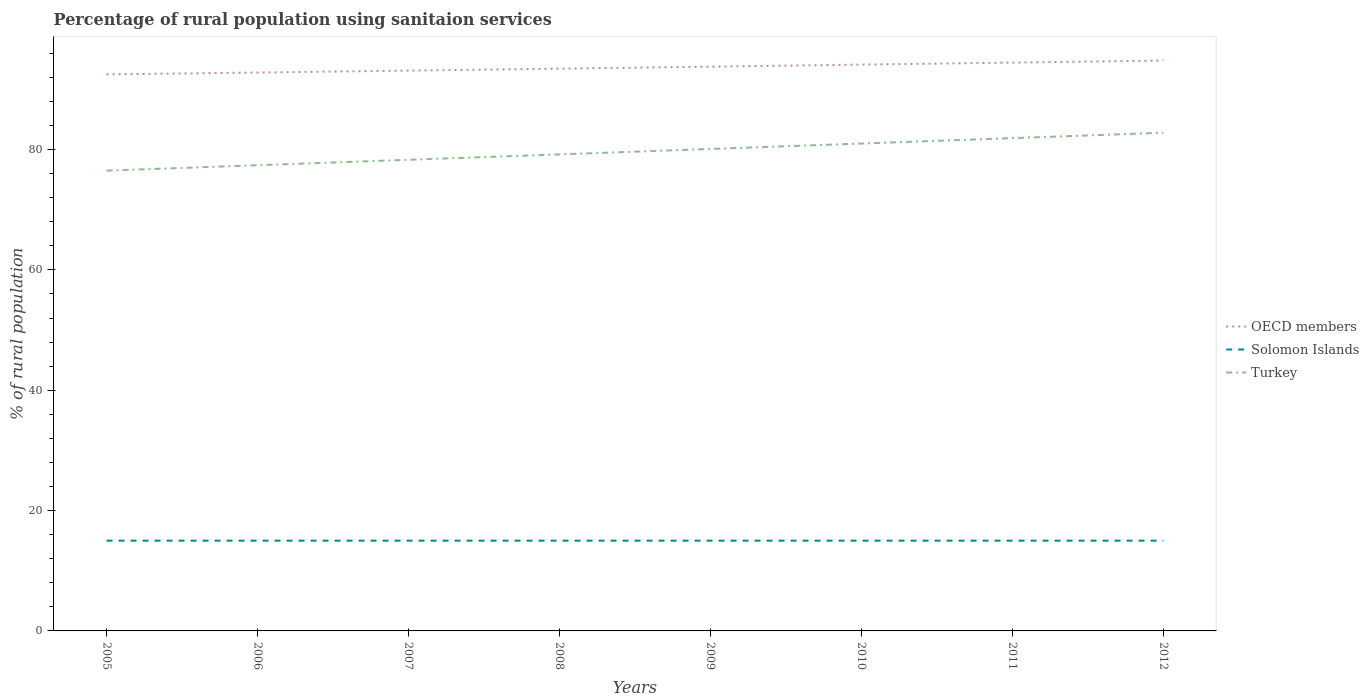Does the line corresponding to OECD members intersect with the line corresponding to Solomon Islands?
Keep it short and to the point. No. Across all years, what is the maximum percentage of rural population using sanitaion services in Solomon Islands?
Make the answer very short. 15. What is the total percentage of rural population using sanitaion services in Turkey in the graph?
Provide a succinct answer. -2.7. What is the difference between the highest and the second highest percentage of rural population using sanitaion services in OECD members?
Provide a succinct answer. 2.29. What is the difference between the highest and the lowest percentage of rural population using sanitaion services in Turkey?
Your answer should be very brief. 4. How many lines are there?
Your answer should be compact. 3. What is the difference between two consecutive major ticks on the Y-axis?
Ensure brevity in your answer.  20. Does the graph contain grids?
Your answer should be compact. No. Where does the legend appear in the graph?
Offer a terse response. Center right. How many legend labels are there?
Your response must be concise. 3. What is the title of the graph?
Provide a succinct answer. Percentage of rural population using sanitaion services. What is the label or title of the X-axis?
Give a very brief answer. Years. What is the label or title of the Y-axis?
Your answer should be compact. % of rural population. What is the % of rural population of OECD members in 2005?
Make the answer very short. 92.5. What is the % of rural population in Solomon Islands in 2005?
Provide a short and direct response. 15. What is the % of rural population of Turkey in 2005?
Your response must be concise. 76.5. What is the % of rural population of OECD members in 2006?
Your response must be concise. 92.8. What is the % of rural population in Turkey in 2006?
Your response must be concise. 77.4. What is the % of rural population of OECD members in 2007?
Provide a succinct answer. 93.13. What is the % of rural population of Solomon Islands in 2007?
Offer a very short reply. 15. What is the % of rural population in Turkey in 2007?
Make the answer very short. 78.3. What is the % of rural population in OECD members in 2008?
Keep it short and to the point. 93.44. What is the % of rural population in Solomon Islands in 2008?
Offer a very short reply. 15. What is the % of rural population in Turkey in 2008?
Make the answer very short. 79.2. What is the % of rural population in OECD members in 2009?
Offer a very short reply. 93.77. What is the % of rural population in Turkey in 2009?
Provide a succinct answer. 80.1. What is the % of rural population of OECD members in 2010?
Provide a succinct answer. 94.12. What is the % of rural population in Solomon Islands in 2010?
Offer a very short reply. 15. What is the % of rural population in Turkey in 2010?
Make the answer very short. 81. What is the % of rural population of OECD members in 2011?
Offer a terse response. 94.45. What is the % of rural population of Solomon Islands in 2011?
Give a very brief answer. 15. What is the % of rural population of Turkey in 2011?
Offer a terse response. 81.9. What is the % of rural population in OECD members in 2012?
Ensure brevity in your answer.  94.79. What is the % of rural population of Solomon Islands in 2012?
Ensure brevity in your answer.  15. What is the % of rural population of Turkey in 2012?
Give a very brief answer. 82.8. Across all years, what is the maximum % of rural population in OECD members?
Your answer should be very brief. 94.79. Across all years, what is the maximum % of rural population in Turkey?
Make the answer very short. 82.8. Across all years, what is the minimum % of rural population in OECD members?
Ensure brevity in your answer.  92.5. Across all years, what is the minimum % of rural population in Turkey?
Provide a short and direct response. 76.5. What is the total % of rural population in OECD members in the graph?
Offer a terse response. 749. What is the total % of rural population of Solomon Islands in the graph?
Offer a very short reply. 120. What is the total % of rural population in Turkey in the graph?
Keep it short and to the point. 637.2. What is the difference between the % of rural population of OECD members in 2005 and that in 2006?
Provide a short and direct response. -0.31. What is the difference between the % of rural population in Solomon Islands in 2005 and that in 2006?
Provide a short and direct response. 0. What is the difference between the % of rural population in Turkey in 2005 and that in 2006?
Your answer should be very brief. -0.9. What is the difference between the % of rural population of OECD members in 2005 and that in 2007?
Your answer should be very brief. -0.63. What is the difference between the % of rural population in Solomon Islands in 2005 and that in 2007?
Your answer should be very brief. 0. What is the difference between the % of rural population in Turkey in 2005 and that in 2007?
Your response must be concise. -1.8. What is the difference between the % of rural population of OECD members in 2005 and that in 2008?
Provide a short and direct response. -0.95. What is the difference between the % of rural population of OECD members in 2005 and that in 2009?
Give a very brief answer. -1.28. What is the difference between the % of rural population in OECD members in 2005 and that in 2010?
Offer a terse response. -1.63. What is the difference between the % of rural population of Solomon Islands in 2005 and that in 2010?
Ensure brevity in your answer.  0. What is the difference between the % of rural population of OECD members in 2005 and that in 2011?
Keep it short and to the point. -1.96. What is the difference between the % of rural population in Solomon Islands in 2005 and that in 2011?
Offer a very short reply. 0. What is the difference between the % of rural population of Turkey in 2005 and that in 2011?
Keep it short and to the point. -5.4. What is the difference between the % of rural population in OECD members in 2005 and that in 2012?
Provide a succinct answer. -2.29. What is the difference between the % of rural population in Solomon Islands in 2005 and that in 2012?
Your answer should be very brief. 0. What is the difference between the % of rural population in Turkey in 2005 and that in 2012?
Your response must be concise. -6.3. What is the difference between the % of rural population in OECD members in 2006 and that in 2007?
Offer a terse response. -0.32. What is the difference between the % of rural population of OECD members in 2006 and that in 2008?
Offer a terse response. -0.64. What is the difference between the % of rural population in OECD members in 2006 and that in 2009?
Your answer should be very brief. -0.97. What is the difference between the % of rural population in OECD members in 2006 and that in 2010?
Keep it short and to the point. -1.32. What is the difference between the % of rural population of Solomon Islands in 2006 and that in 2010?
Offer a very short reply. 0. What is the difference between the % of rural population in OECD members in 2006 and that in 2011?
Keep it short and to the point. -1.65. What is the difference between the % of rural population in Solomon Islands in 2006 and that in 2011?
Your answer should be very brief. 0. What is the difference between the % of rural population in Turkey in 2006 and that in 2011?
Provide a succinct answer. -4.5. What is the difference between the % of rural population of OECD members in 2006 and that in 2012?
Give a very brief answer. -1.99. What is the difference between the % of rural population of Solomon Islands in 2006 and that in 2012?
Make the answer very short. 0. What is the difference between the % of rural population in OECD members in 2007 and that in 2008?
Your response must be concise. -0.32. What is the difference between the % of rural population of Turkey in 2007 and that in 2008?
Ensure brevity in your answer.  -0.9. What is the difference between the % of rural population of OECD members in 2007 and that in 2009?
Provide a succinct answer. -0.65. What is the difference between the % of rural population in Turkey in 2007 and that in 2009?
Your answer should be compact. -1.8. What is the difference between the % of rural population in OECD members in 2007 and that in 2010?
Offer a very short reply. -1. What is the difference between the % of rural population of OECD members in 2007 and that in 2011?
Give a very brief answer. -1.33. What is the difference between the % of rural population in Solomon Islands in 2007 and that in 2011?
Your response must be concise. 0. What is the difference between the % of rural population in OECD members in 2007 and that in 2012?
Offer a very short reply. -1.66. What is the difference between the % of rural population of Solomon Islands in 2007 and that in 2012?
Provide a short and direct response. 0. What is the difference between the % of rural population of Turkey in 2007 and that in 2012?
Offer a very short reply. -4.5. What is the difference between the % of rural population of OECD members in 2008 and that in 2009?
Offer a terse response. -0.33. What is the difference between the % of rural population in OECD members in 2008 and that in 2010?
Provide a short and direct response. -0.68. What is the difference between the % of rural population in Turkey in 2008 and that in 2010?
Give a very brief answer. -1.8. What is the difference between the % of rural population of OECD members in 2008 and that in 2011?
Give a very brief answer. -1.01. What is the difference between the % of rural population of Solomon Islands in 2008 and that in 2011?
Provide a succinct answer. 0. What is the difference between the % of rural population in OECD members in 2008 and that in 2012?
Provide a short and direct response. -1.35. What is the difference between the % of rural population of Turkey in 2008 and that in 2012?
Your response must be concise. -3.6. What is the difference between the % of rural population of OECD members in 2009 and that in 2010?
Your answer should be very brief. -0.35. What is the difference between the % of rural population of OECD members in 2009 and that in 2011?
Offer a terse response. -0.68. What is the difference between the % of rural population in OECD members in 2009 and that in 2012?
Your response must be concise. -1.01. What is the difference between the % of rural population in Solomon Islands in 2009 and that in 2012?
Your response must be concise. 0. What is the difference between the % of rural population in Turkey in 2009 and that in 2012?
Keep it short and to the point. -2.7. What is the difference between the % of rural population of OECD members in 2010 and that in 2011?
Give a very brief answer. -0.33. What is the difference between the % of rural population in OECD members in 2010 and that in 2012?
Your response must be concise. -0.67. What is the difference between the % of rural population in Solomon Islands in 2010 and that in 2012?
Your answer should be compact. 0. What is the difference between the % of rural population of OECD members in 2011 and that in 2012?
Keep it short and to the point. -0.34. What is the difference between the % of rural population in Turkey in 2011 and that in 2012?
Ensure brevity in your answer.  -0.9. What is the difference between the % of rural population of OECD members in 2005 and the % of rural population of Solomon Islands in 2006?
Offer a terse response. 77.5. What is the difference between the % of rural population in OECD members in 2005 and the % of rural population in Turkey in 2006?
Give a very brief answer. 15.1. What is the difference between the % of rural population of Solomon Islands in 2005 and the % of rural population of Turkey in 2006?
Your answer should be compact. -62.4. What is the difference between the % of rural population of OECD members in 2005 and the % of rural population of Solomon Islands in 2007?
Provide a succinct answer. 77.5. What is the difference between the % of rural population of OECD members in 2005 and the % of rural population of Turkey in 2007?
Your answer should be very brief. 14.2. What is the difference between the % of rural population in Solomon Islands in 2005 and the % of rural population in Turkey in 2007?
Give a very brief answer. -63.3. What is the difference between the % of rural population of OECD members in 2005 and the % of rural population of Solomon Islands in 2008?
Make the answer very short. 77.5. What is the difference between the % of rural population of OECD members in 2005 and the % of rural population of Turkey in 2008?
Your answer should be compact. 13.3. What is the difference between the % of rural population of Solomon Islands in 2005 and the % of rural population of Turkey in 2008?
Offer a terse response. -64.2. What is the difference between the % of rural population of OECD members in 2005 and the % of rural population of Solomon Islands in 2009?
Give a very brief answer. 77.5. What is the difference between the % of rural population of OECD members in 2005 and the % of rural population of Turkey in 2009?
Offer a very short reply. 12.4. What is the difference between the % of rural population in Solomon Islands in 2005 and the % of rural population in Turkey in 2009?
Offer a very short reply. -65.1. What is the difference between the % of rural population of OECD members in 2005 and the % of rural population of Solomon Islands in 2010?
Your response must be concise. 77.5. What is the difference between the % of rural population in OECD members in 2005 and the % of rural population in Turkey in 2010?
Keep it short and to the point. 11.5. What is the difference between the % of rural population in Solomon Islands in 2005 and the % of rural population in Turkey in 2010?
Your response must be concise. -66. What is the difference between the % of rural population in OECD members in 2005 and the % of rural population in Solomon Islands in 2011?
Make the answer very short. 77.5. What is the difference between the % of rural population of OECD members in 2005 and the % of rural population of Turkey in 2011?
Your answer should be very brief. 10.6. What is the difference between the % of rural population in Solomon Islands in 2005 and the % of rural population in Turkey in 2011?
Your response must be concise. -66.9. What is the difference between the % of rural population in OECD members in 2005 and the % of rural population in Solomon Islands in 2012?
Provide a short and direct response. 77.5. What is the difference between the % of rural population of OECD members in 2005 and the % of rural population of Turkey in 2012?
Your response must be concise. 9.7. What is the difference between the % of rural population in Solomon Islands in 2005 and the % of rural population in Turkey in 2012?
Provide a succinct answer. -67.8. What is the difference between the % of rural population of OECD members in 2006 and the % of rural population of Solomon Islands in 2007?
Provide a succinct answer. 77.8. What is the difference between the % of rural population of OECD members in 2006 and the % of rural population of Turkey in 2007?
Give a very brief answer. 14.5. What is the difference between the % of rural population in Solomon Islands in 2006 and the % of rural population in Turkey in 2007?
Make the answer very short. -63.3. What is the difference between the % of rural population of OECD members in 2006 and the % of rural population of Solomon Islands in 2008?
Your answer should be very brief. 77.8. What is the difference between the % of rural population of OECD members in 2006 and the % of rural population of Turkey in 2008?
Give a very brief answer. 13.6. What is the difference between the % of rural population in Solomon Islands in 2006 and the % of rural population in Turkey in 2008?
Ensure brevity in your answer.  -64.2. What is the difference between the % of rural population of OECD members in 2006 and the % of rural population of Solomon Islands in 2009?
Keep it short and to the point. 77.8. What is the difference between the % of rural population in OECD members in 2006 and the % of rural population in Turkey in 2009?
Give a very brief answer. 12.7. What is the difference between the % of rural population in Solomon Islands in 2006 and the % of rural population in Turkey in 2009?
Provide a succinct answer. -65.1. What is the difference between the % of rural population of OECD members in 2006 and the % of rural population of Solomon Islands in 2010?
Give a very brief answer. 77.8. What is the difference between the % of rural population of OECD members in 2006 and the % of rural population of Turkey in 2010?
Ensure brevity in your answer.  11.8. What is the difference between the % of rural population of Solomon Islands in 2006 and the % of rural population of Turkey in 2010?
Give a very brief answer. -66. What is the difference between the % of rural population of OECD members in 2006 and the % of rural population of Solomon Islands in 2011?
Provide a succinct answer. 77.8. What is the difference between the % of rural population of OECD members in 2006 and the % of rural population of Turkey in 2011?
Keep it short and to the point. 10.9. What is the difference between the % of rural population of Solomon Islands in 2006 and the % of rural population of Turkey in 2011?
Make the answer very short. -66.9. What is the difference between the % of rural population of OECD members in 2006 and the % of rural population of Solomon Islands in 2012?
Make the answer very short. 77.8. What is the difference between the % of rural population in OECD members in 2006 and the % of rural population in Turkey in 2012?
Offer a terse response. 10. What is the difference between the % of rural population in Solomon Islands in 2006 and the % of rural population in Turkey in 2012?
Ensure brevity in your answer.  -67.8. What is the difference between the % of rural population in OECD members in 2007 and the % of rural population in Solomon Islands in 2008?
Keep it short and to the point. 78.13. What is the difference between the % of rural population of OECD members in 2007 and the % of rural population of Turkey in 2008?
Give a very brief answer. 13.93. What is the difference between the % of rural population in Solomon Islands in 2007 and the % of rural population in Turkey in 2008?
Your response must be concise. -64.2. What is the difference between the % of rural population of OECD members in 2007 and the % of rural population of Solomon Islands in 2009?
Offer a terse response. 78.13. What is the difference between the % of rural population of OECD members in 2007 and the % of rural population of Turkey in 2009?
Offer a very short reply. 13.03. What is the difference between the % of rural population in Solomon Islands in 2007 and the % of rural population in Turkey in 2009?
Ensure brevity in your answer.  -65.1. What is the difference between the % of rural population in OECD members in 2007 and the % of rural population in Solomon Islands in 2010?
Provide a short and direct response. 78.13. What is the difference between the % of rural population of OECD members in 2007 and the % of rural population of Turkey in 2010?
Keep it short and to the point. 12.13. What is the difference between the % of rural population in Solomon Islands in 2007 and the % of rural population in Turkey in 2010?
Give a very brief answer. -66. What is the difference between the % of rural population of OECD members in 2007 and the % of rural population of Solomon Islands in 2011?
Give a very brief answer. 78.13. What is the difference between the % of rural population in OECD members in 2007 and the % of rural population in Turkey in 2011?
Make the answer very short. 11.23. What is the difference between the % of rural population of Solomon Islands in 2007 and the % of rural population of Turkey in 2011?
Keep it short and to the point. -66.9. What is the difference between the % of rural population of OECD members in 2007 and the % of rural population of Solomon Islands in 2012?
Provide a succinct answer. 78.13. What is the difference between the % of rural population of OECD members in 2007 and the % of rural population of Turkey in 2012?
Keep it short and to the point. 10.33. What is the difference between the % of rural population in Solomon Islands in 2007 and the % of rural population in Turkey in 2012?
Offer a terse response. -67.8. What is the difference between the % of rural population of OECD members in 2008 and the % of rural population of Solomon Islands in 2009?
Give a very brief answer. 78.44. What is the difference between the % of rural population in OECD members in 2008 and the % of rural population in Turkey in 2009?
Give a very brief answer. 13.34. What is the difference between the % of rural population in Solomon Islands in 2008 and the % of rural population in Turkey in 2009?
Give a very brief answer. -65.1. What is the difference between the % of rural population in OECD members in 2008 and the % of rural population in Solomon Islands in 2010?
Offer a very short reply. 78.44. What is the difference between the % of rural population of OECD members in 2008 and the % of rural population of Turkey in 2010?
Ensure brevity in your answer.  12.44. What is the difference between the % of rural population of Solomon Islands in 2008 and the % of rural population of Turkey in 2010?
Your response must be concise. -66. What is the difference between the % of rural population in OECD members in 2008 and the % of rural population in Solomon Islands in 2011?
Give a very brief answer. 78.44. What is the difference between the % of rural population in OECD members in 2008 and the % of rural population in Turkey in 2011?
Provide a succinct answer. 11.54. What is the difference between the % of rural population of Solomon Islands in 2008 and the % of rural population of Turkey in 2011?
Provide a short and direct response. -66.9. What is the difference between the % of rural population in OECD members in 2008 and the % of rural population in Solomon Islands in 2012?
Offer a very short reply. 78.44. What is the difference between the % of rural population in OECD members in 2008 and the % of rural population in Turkey in 2012?
Your answer should be compact. 10.64. What is the difference between the % of rural population in Solomon Islands in 2008 and the % of rural population in Turkey in 2012?
Provide a succinct answer. -67.8. What is the difference between the % of rural population in OECD members in 2009 and the % of rural population in Solomon Islands in 2010?
Make the answer very short. 78.77. What is the difference between the % of rural population of OECD members in 2009 and the % of rural population of Turkey in 2010?
Provide a short and direct response. 12.77. What is the difference between the % of rural population of Solomon Islands in 2009 and the % of rural population of Turkey in 2010?
Provide a short and direct response. -66. What is the difference between the % of rural population of OECD members in 2009 and the % of rural population of Solomon Islands in 2011?
Make the answer very short. 78.77. What is the difference between the % of rural population in OECD members in 2009 and the % of rural population in Turkey in 2011?
Your answer should be compact. 11.87. What is the difference between the % of rural population in Solomon Islands in 2009 and the % of rural population in Turkey in 2011?
Offer a very short reply. -66.9. What is the difference between the % of rural population in OECD members in 2009 and the % of rural population in Solomon Islands in 2012?
Provide a succinct answer. 78.77. What is the difference between the % of rural population in OECD members in 2009 and the % of rural population in Turkey in 2012?
Offer a terse response. 10.97. What is the difference between the % of rural population in Solomon Islands in 2009 and the % of rural population in Turkey in 2012?
Your response must be concise. -67.8. What is the difference between the % of rural population of OECD members in 2010 and the % of rural population of Solomon Islands in 2011?
Offer a terse response. 79.12. What is the difference between the % of rural population in OECD members in 2010 and the % of rural population in Turkey in 2011?
Provide a succinct answer. 12.22. What is the difference between the % of rural population of Solomon Islands in 2010 and the % of rural population of Turkey in 2011?
Your answer should be compact. -66.9. What is the difference between the % of rural population of OECD members in 2010 and the % of rural population of Solomon Islands in 2012?
Offer a very short reply. 79.12. What is the difference between the % of rural population of OECD members in 2010 and the % of rural population of Turkey in 2012?
Offer a terse response. 11.32. What is the difference between the % of rural population in Solomon Islands in 2010 and the % of rural population in Turkey in 2012?
Your answer should be compact. -67.8. What is the difference between the % of rural population in OECD members in 2011 and the % of rural population in Solomon Islands in 2012?
Ensure brevity in your answer.  79.45. What is the difference between the % of rural population of OECD members in 2011 and the % of rural population of Turkey in 2012?
Give a very brief answer. 11.65. What is the difference between the % of rural population of Solomon Islands in 2011 and the % of rural population of Turkey in 2012?
Your response must be concise. -67.8. What is the average % of rural population in OECD members per year?
Offer a very short reply. 93.63. What is the average % of rural population in Turkey per year?
Your answer should be compact. 79.65. In the year 2005, what is the difference between the % of rural population of OECD members and % of rural population of Solomon Islands?
Provide a short and direct response. 77.5. In the year 2005, what is the difference between the % of rural population of OECD members and % of rural population of Turkey?
Offer a very short reply. 16. In the year 2005, what is the difference between the % of rural population in Solomon Islands and % of rural population in Turkey?
Provide a succinct answer. -61.5. In the year 2006, what is the difference between the % of rural population of OECD members and % of rural population of Solomon Islands?
Your answer should be very brief. 77.8. In the year 2006, what is the difference between the % of rural population in OECD members and % of rural population in Turkey?
Offer a terse response. 15.4. In the year 2006, what is the difference between the % of rural population of Solomon Islands and % of rural population of Turkey?
Keep it short and to the point. -62.4. In the year 2007, what is the difference between the % of rural population in OECD members and % of rural population in Solomon Islands?
Your answer should be very brief. 78.13. In the year 2007, what is the difference between the % of rural population in OECD members and % of rural population in Turkey?
Make the answer very short. 14.83. In the year 2007, what is the difference between the % of rural population in Solomon Islands and % of rural population in Turkey?
Your answer should be very brief. -63.3. In the year 2008, what is the difference between the % of rural population of OECD members and % of rural population of Solomon Islands?
Your response must be concise. 78.44. In the year 2008, what is the difference between the % of rural population of OECD members and % of rural population of Turkey?
Provide a succinct answer. 14.24. In the year 2008, what is the difference between the % of rural population of Solomon Islands and % of rural population of Turkey?
Provide a succinct answer. -64.2. In the year 2009, what is the difference between the % of rural population of OECD members and % of rural population of Solomon Islands?
Your answer should be compact. 78.77. In the year 2009, what is the difference between the % of rural population of OECD members and % of rural population of Turkey?
Ensure brevity in your answer.  13.67. In the year 2009, what is the difference between the % of rural population of Solomon Islands and % of rural population of Turkey?
Provide a short and direct response. -65.1. In the year 2010, what is the difference between the % of rural population of OECD members and % of rural population of Solomon Islands?
Your answer should be compact. 79.12. In the year 2010, what is the difference between the % of rural population of OECD members and % of rural population of Turkey?
Offer a very short reply. 13.12. In the year 2010, what is the difference between the % of rural population in Solomon Islands and % of rural population in Turkey?
Offer a very short reply. -66. In the year 2011, what is the difference between the % of rural population in OECD members and % of rural population in Solomon Islands?
Provide a succinct answer. 79.45. In the year 2011, what is the difference between the % of rural population in OECD members and % of rural population in Turkey?
Ensure brevity in your answer.  12.55. In the year 2011, what is the difference between the % of rural population in Solomon Islands and % of rural population in Turkey?
Give a very brief answer. -66.9. In the year 2012, what is the difference between the % of rural population of OECD members and % of rural population of Solomon Islands?
Keep it short and to the point. 79.79. In the year 2012, what is the difference between the % of rural population in OECD members and % of rural population in Turkey?
Provide a succinct answer. 11.99. In the year 2012, what is the difference between the % of rural population in Solomon Islands and % of rural population in Turkey?
Provide a short and direct response. -67.8. What is the ratio of the % of rural population in OECD members in 2005 to that in 2006?
Make the answer very short. 1. What is the ratio of the % of rural population of Solomon Islands in 2005 to that in 2006?
Your answer should be compact. 1. What is the ratio of the % of rural population of Turkey in 2005 to that in 2006?
Make the answer very short. 0.99. What is the ratio of the % of rural population of OECD members in 2005 to that in 2007?
Your answer should be compact. 0.99. What is the ratio of the % of rural population of Turkey in 2005 to that in 2007?
Give a very brief answer. 0.98. What is the ratio of the % of rural population in OECD members in 2005 to that in 2008?
Keep it short and to the point. 0.99. What is the ratio of the % of rural population of Solomon Islands in 2005 to that in 2008?
Offer a very short reply. 1. What is the ratio of the % of rural population of Turkey in 2005 to that in 2008?
Your answer should be very brief. 0.97. What is the ratio of the % of rural population of OECD members in 2005 to that in 2009?
Keep it short and to the point. 0.99. What is the ratio of the % of rural population in Solomon Islands in 2005 to that in 2009?
Make the answer very short. 1. What is the ratio of the % of rural population in Turkey in 2005 to that in 2009?
Offer a terse response. 0.96. What is the ratio of the % of rural population in OECD members in 2005 to that in 2010?
Keep it short and to the point. 0.98. What is the ratio of the % of rural population of OECD members in 2005 to that in 2011?
Provide a short and direct response. 0.98. What is the ratio of the % of rural population of Solomon Islands in 2005 to that in 2011?
Ensure brevity in your answer.  1. What is the ratio of the % of rural population of Turkey in 2005 to that in 2011?
Ensure brevity in your answer.  0.93. What is the ratio of the % of rural population of OECD members in 2005 to that in 2012?
Make the answer very short. 0.98. What is the ratio of the % of rural population of Turkey in 2005 to that in 2012?
Provide a succinct answer. 0.92. What is the ratio of the % of rural population of OECD members in 2006 to that in 2007?
Your answer should be very brief. 1. What is the ratio of the % of rural population of Solomon Islands in 2006 to that in 2007?
Offer a very short reply. 1. What is the ratio of the % of rural population in OECD members in 2006 to that in 2008?
Keep it short and to the point. 0.99. What is the ratio of the % of rural population of Turkey in 2006 to that in 2008?
Provide a succinct answer. 0.98. What is the ratio of the % of rural population of Solomon Islands in 2006 to that in 2009?
Provide a succinct answer. 1. What is the ratio of the % of rural population in Turkey in 2006 to that in 2009?
Provide a succinct answer. 0.97. What is the ratio of the % of rural population in OECD members in 2006 to that in 2010?
Give a very brief answer. 0.99. What is the ratio of the % of rural population in Turkey in 2006 to that in 2010?
Provide a succinct answer. 0.96. What is the ratio of the % of rural population in OECD members in 2006 to that in 2011?
Your answer should be compact. 0.98. What is the ratio of the % of rural population in Solomon Islands in 2006 to that in 2011?
Make the answer very short. 1. What is the ratio of the % of rural population in Turkey in 2006 to that in 2011?
Your response must be concise. 0.95. What is the ratio of the % of rural population in Turkey in 2006 to that in 2012?
Provide a succinct answer. 0.93. What is the ratio of the % of rural population of OECD members in 2007 to that in 2009?
Provide a short and direct response. 0.99. What is the ratio of the % of rural population in Turkey in 2007 to that in 2009?
Your response must be concise. 0.98. What is the ratio of the % of rural population of Solomon Islands in 2007 to that in 2010?
Offer a very short reply. 1. What is the ratio of the % of rural population of Turkey in 2007 to that in 2010?
Keep it short and to the point. 0.97. What is the ratio of the % of rural population of Turkey in 2007 to that in 2011?
Make the answer very short. 0.96. What is the ratio of the % of rural population in OECD members in 2007 to that in 2012?
Your answer should be very brief. 0.98. What is the ratio of the % of rural population in Solomon Islands in 2007 to that in 2012?
Your answer should be very brief. 1. What is the ratio of the % of rural population of Turkey in 2007 to that in 2012?
Offer a very short reply. 0.95. What is the ratio of the % of rural population of OECD members in 2008 to that in 2009?
Provide a short and direct response. 1. What is the ratio of the % of rural population of Solomon Islands in 2008 to that in 2010?
Make the answer very short. 1. What is the ratio of the % of rural population in Turkey in 2008 to that in 2010?
Keep it short and to the point. 0.98. What is the ratio of the % of rural population of OECD members in 2008 to that in 2011?
Ensure brevity in your answer.  0.99. What is the ratio of the % of rural population of Solomon Islands in 2008 to that in 2011?
Your answer should be very brief. 1. What is the ratio of the % of rural population in Turkey in 2008 to that in 2011?
Offer a terse response. 0.97. What is the ratio of the % of rural population of OECD members in 2008 to that in 2012?
Give a very brief answer. 0.99. What is the ratio of the % of rural population in Turkey in 2008 to that in 2012?
Your answer should be compact. 0.96. What is the ratio of the % of rural population of OECD members in 2009 to that in 2010?
Offer a terse response. 1. What is the ratio of the % of rural population of Solomon Islands in 2009 to that in 2010?
Ensure brevity in your answer.  1. What is the ratio of the % of rural population in Turkey in 2009 to that in 2010?
Ensure brevity in your answer.  0.99. What is the ratio of the % of rural population in Solomon Islands in 2009 to that in 2011?
Ensure brevity in your answer.  1. What is the ratio of the % of rural population of Turkey in 2009 to that in 2011?
Offer a very short reply. 0.98. What is the ratio of the % of rural population of OECD members in 2009 to that in 2012?
Your answer should be compact. 0.99. What is the ratio of the % of rural population in Turkey in 2009 to that in 2012?
Your response must be concise. 0.97. What is the ratio of the % of rural population in OECD members in 2010 to that in 2012?
Provide a short and direct response. 0.99. What is the ratio of the % of rural population of Solomon Islands in 2010 to that in 2012?
Offer a terse response. 1. What is the ratio of the % of rural population in Turkey in 2010 to that in 2012?
Offer a very short reply. 0.98. What is the ratio of the % of rural population of Turkey in 2011 to that in 2012?
Ensure brevity in your answer.  0.99. What is the difference between the highest and the second highest % of rural population of OECD members?
Provide a short and direct response. 0.34. What is the difference between the highest and the second highest % of rural population of Solomon Islands?
Give a very brief answer. 0. What is the difference between the highest and the lowest % of rural population of OECD members?
Your answer should be very brief. 2.29. What is the difference between the highest and the lowest % of rural population in Turkey?
Your response must be concise. 6.3. 